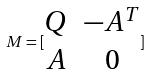<formula> <loc_0><loc_0><loc_500><loc_500>M = [ \begin{matrix} Q & - A ^ { T } \\ A & 0 \end{matrix} ]</formula> 